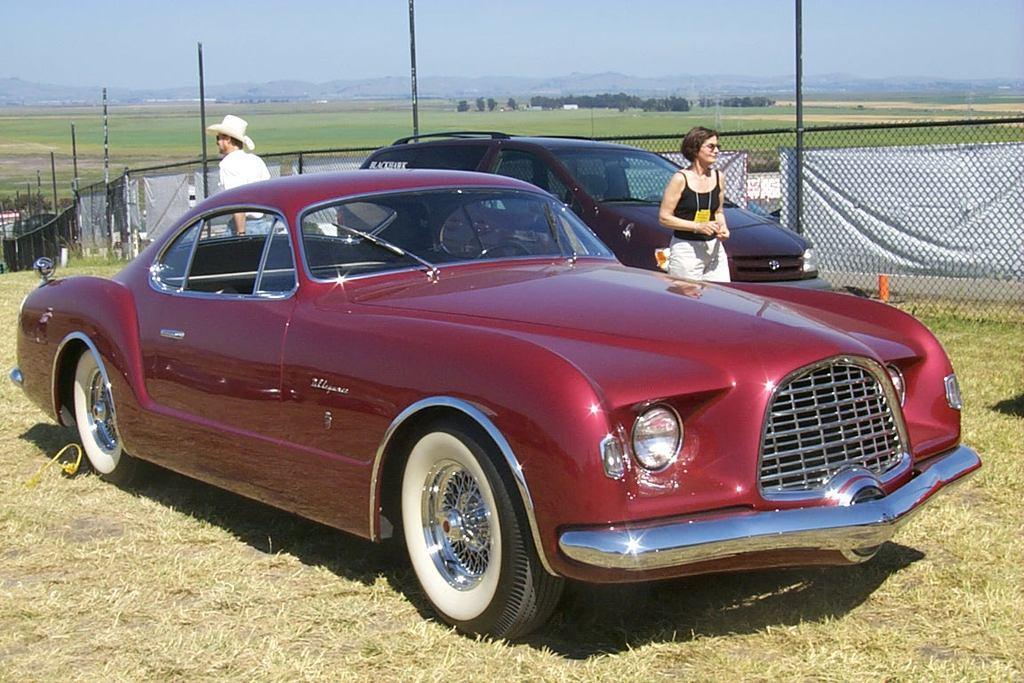How would you summarize this image in a sentence or two? In this image we can see two vehicles. Behind the vehicles we can see two persons, poles, fencing, grass, a group of trees and mountains. At the top we can see the sky. 